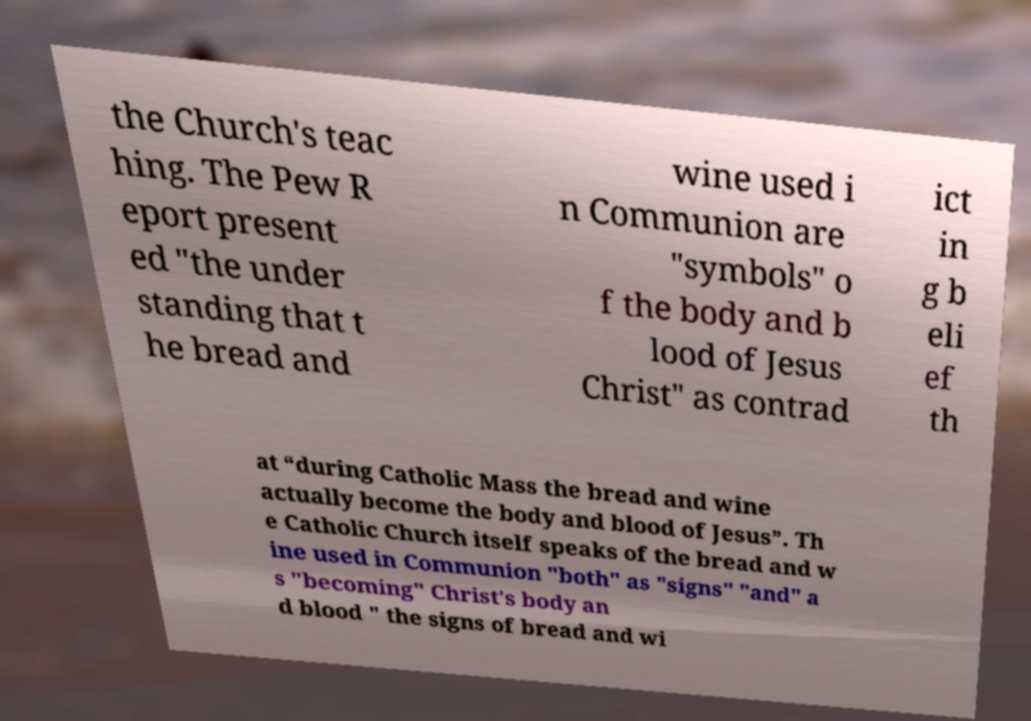I need the written content from this picture converted into text. Can you do that? the Church's teac hing. The Pew R eport present ed "the under standing that t he bread and wine used i n Communion are "symbols" o f the body and b lood of Jesus Christ" as contrad ict in g b eli ef th at “during Catholic Mass the bread and wine actually become the body and blood of Jesus”. Th e Catholic Church itself speaks of the bread and w ine used in Communion "both" as "signs" "and" a s "becoming" Christ's body an d blood " the signs of bread and wi 